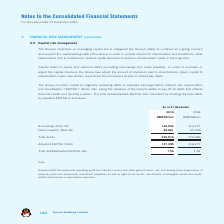According to Tencent's financial document, What is the amount of borrowings as at 31 December 2019? According to the financial document, 126,952 (in millions). The relevant text states: "Borrowings (Note 35) 126,952 114,271..." Also, What is the amount of borrowings as at 31 December 2018? According to the financial document, 114,271 (in millions). The relevant text states: "Borrowings (Note 35) 126,952 114,271..." Also, What is the amount of notes payable as at 31 December 2019? According to the financial document, 93,861 (in millions). The relevant text states: "Notes payable (Note 36) 93,861 65,018..." Also, can you calculate: How much did borrowings change from 2018 year end to 2019 year end? Based on the calculation: 126,952-114,271, the result is 12681 (in millions). This is based on the information: "Borrowings (Note 35) 126,952 114,271 Borrowings (Note 35) 126,952 114,271..." The key data points involved are: 114,271, 126,952. Also, can you calculate: How much did notes payable change from 2018 year end to 2019 year end? Based on the calculation: 93,861-65,018, the result is 28843 (in millions). This is based on the information: "Notes payable (Note 36) 93,861 65,018 Notes payable (Note 36) 93,861 65,018..." The key data points involved are: 65,018, 93,861. Also, can you calculate: How much did the Adjusted EBITDA change  from 2018 year end to 2019 year end? Based on the calculation: 147,395-118,273, the result is 29122 (in millions). This is based on the information: "Adjusted EBITDA (Note) 147,395 118,273 Adjusted EBITDA (Note) 147,395 118,273..." The key data points involved are: 118,273, 147,395. 